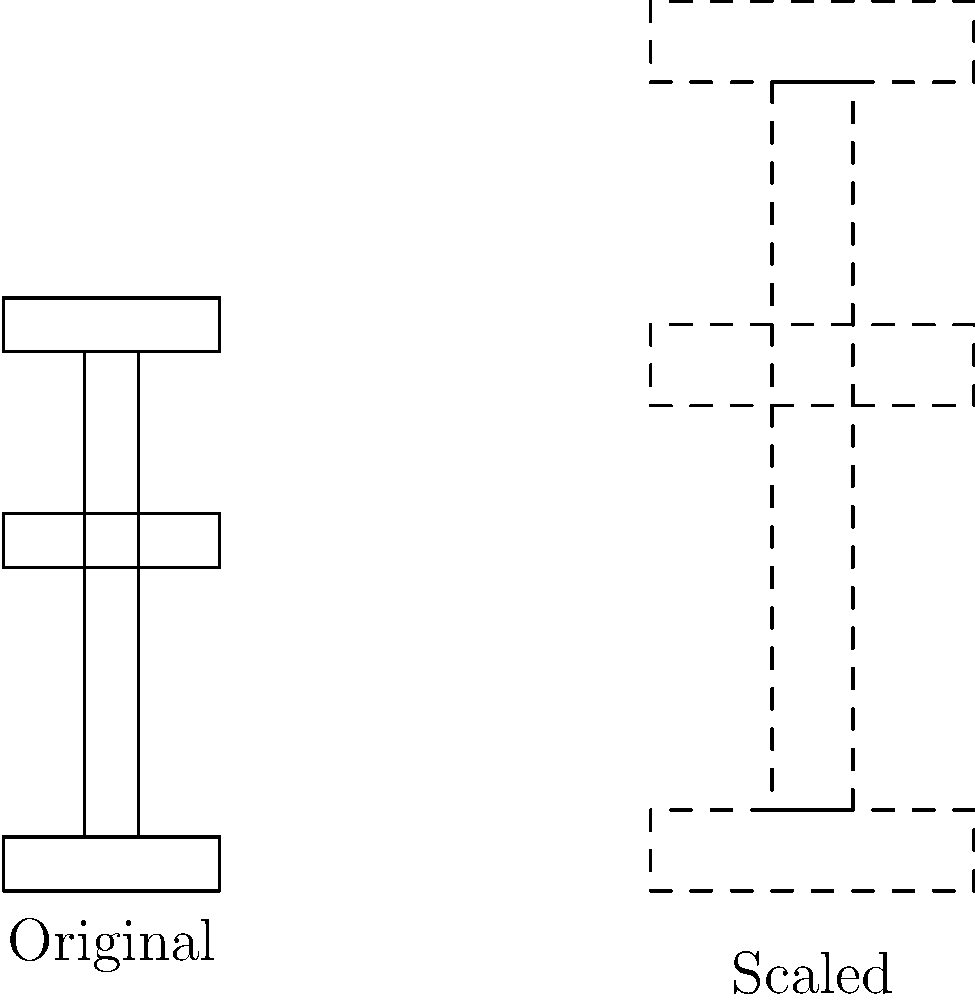You want to upgrade your cat tree to accommodate your growing kitten. If you scale the original cat tree by a factor of 1.5, what will be the new height of the top platform? Let's approach this step-by-step:

1. First, we need to determine the height of the original cat tree. From the diagram, we can see that the top platform is at the same level as the top of the pole.

2. The pole starts at the top of the base (0.5 units) and extends to 5 units high. So the total height of the original cat tree is 5 units.

3. When we scale an object, all its dimensions are multiplied by the scaling factor. In this case, the scaling factor is 1.5.

4. To find the new height, we multiply the original height by the scaling factor:

   $$ \text{New Height} = \text{Original Height} \times \text{Scaling Factor} $$
   $$ \text{New Height} = 5 \times 1.5 = 7.5 \text{ units} $$

5. Therefore, after scaling, the top platform of the cat tree will be at a height of 7.5 units.
Answer: 7.5 units 